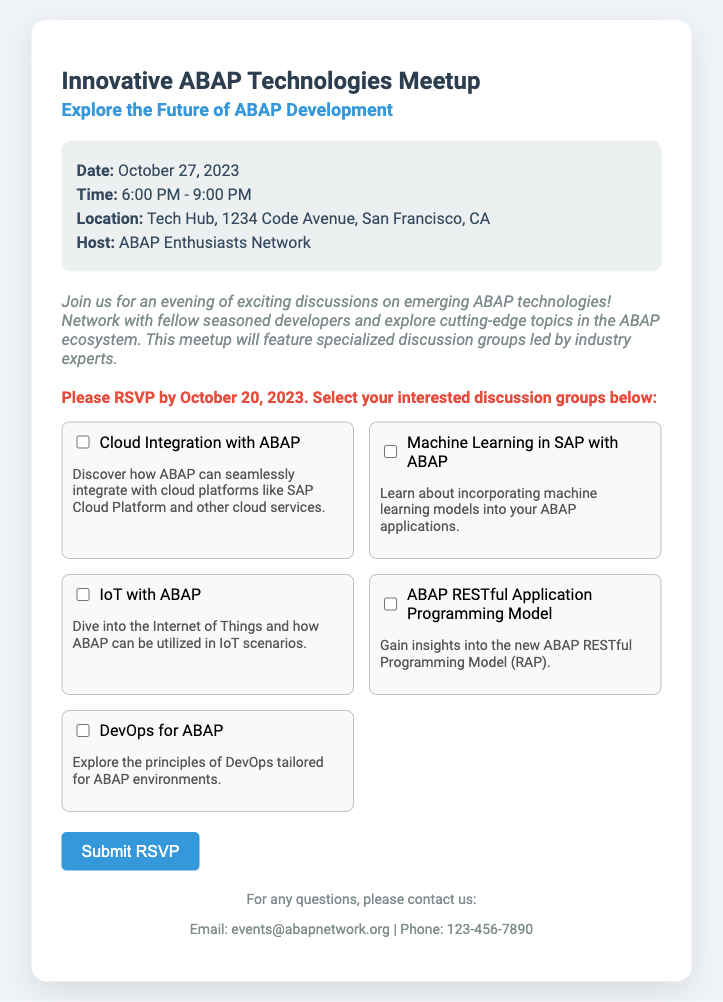what is the date of the meetup? The date of the meetup is explicitly mentioned in the event details section of the document.
Answer: October 27, 2023 what is the location of the event? The location of the event is provided in the event details section.
Answer: Tech Hub, 1234 Code Avenue, San Francisco, CA who is hosting the event? The host of the event is listed in the event details, indicating who is organizing the meetup.
Answer: ABAP Enthusiasts Network what time does the event start? The starting time of the event is specifically detailed in the event details section.
Answer: 6:00 PM which discussion group focuses on cloud technologies? The discussion groups section lists various groups, and the one addressing cloud technologies can be identified.
Answer: Cloud Integration with ABAP how many specialized discussion groups are mentioned in the document? The total number of discussion groups can be calculated by counting them in the discussion groups section.
Answer: Five when is the RSVP deadline? The RSVP deadline is stated clearly in the RSVP instructions section of the document.
Answer: October 20, 2023 what is the purpose of the meetup? The purpose of the meetup is described in the introductory paragraph, outlining the main focus.
Answer: Exciting discussions on emerging ABAP technologies 